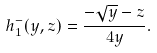Convert formula to latex. <formula><loc_0><loc_0><loc_500><loc_500>h _ { 1 } ^ { - } ( y , z ) = \frac { - \sqrt { y } - z } { 4 y } .</formula> 